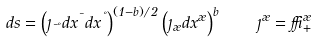Convert formula to latex. <formula><loc_0><loc_0><loc_500><loc_500>d s = \left ( \eta _ { \mu \nu } d x ^ { \mu } d x ^ { \nu } \right ) ^ { ( 1 - b ) / 2 } \left ( \eta _ { \rho } d x ^ { \rho } \right ) ^ { b } \, \quad \eta ^ { \rho } = \delta ^ { \rho } _ { + }</formula> 